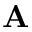<formula> <loc_0><loc_0><loc_500><loc_500>A</formula> 